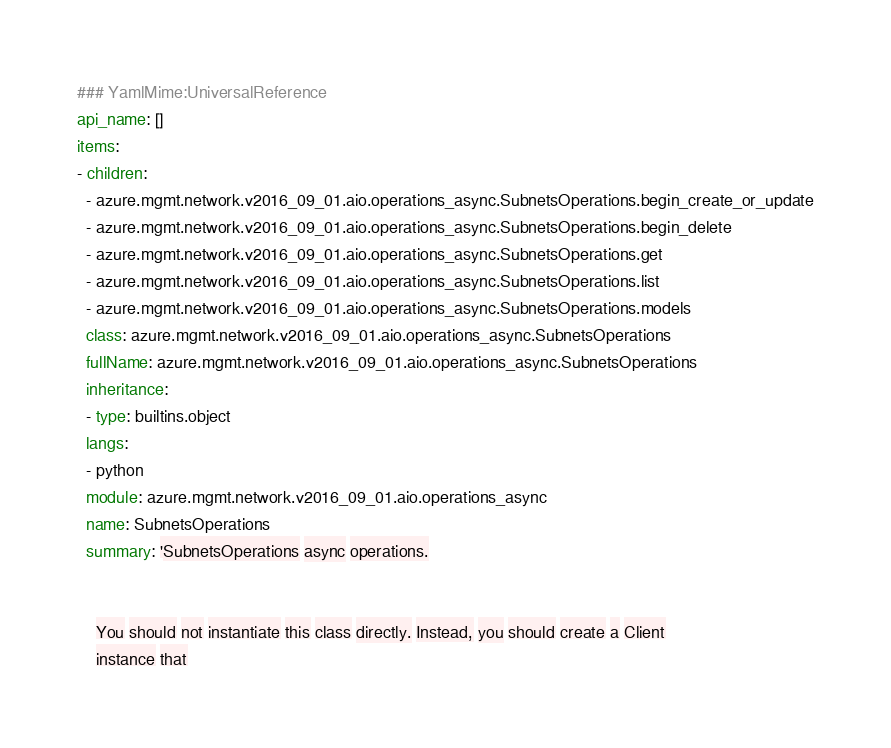Convert code to text. <code><loc_0><loc_0><loc_500><loc_500><_YAML_>### YamlMime:UniversalReference
api_name: []
items:
- children:
  - azure.mgmt.network.v2016_09_01.aio.operations_async.SubnetsOperations.begin_create_or_update
  - azure.mgmt.network.v2016_09_01.aio.operations_async.SubnetsOperations.begin_delete
  - azure.mgmt.network.v2016_09_01.aio.operations_async.SubnetsOperations.get
  - azure.mgmt.network.v2016_09_01.aio.operations_async.SubnetsOperations.list
  - azure.mgmt.network.v2016_09_01.aio.operations_async.SubnetsOperations.models
  class: azure.mgmt.network.v2016_09_01.aio.operations_async.SubnetsOperations
  fullName: azure.mgmt.network.v2016_09_01.aio.operations_async.SubnetsOperations
  inheritance:
  - type: builtins.object
  langs:
  - python
  module: azure.mgmt.network.v2016_09_01.aio.operations_async
  name: SubnetsOperations
  summary: 'SubnetsOperations async operations.


    You should not instantiate this class directly. Instead, you should create a Client
    instance that
</code> 